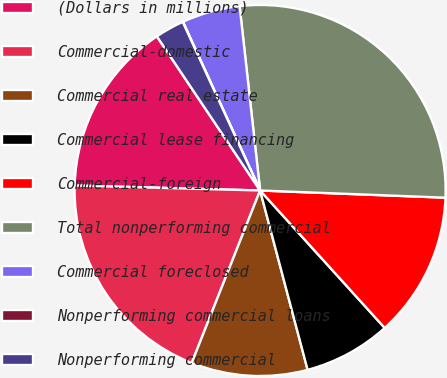<chart> <loc_0><loc_0><loc_500><loc_500><pie_chart><fcel>(Dollars in millions)<fcel>Commercial-domestic<fcel>Commercial real estate<fcel>Commercial lease financing<fcel>Commercial-foreign<fcel>Total nonperforming commercial<fcel>Commercial foreclosed<fcel>Nonperforming commercial loans<fcel>Nonperforming commercial<nl><fcel>15.18%<fcel>19.42%<fcel>10.13%<fcel>7.6%<fcel>12.66%<fcel>27.38%<fcel>5.07%<fcel>0.02%<fcel>2.54%<nl></chart> 